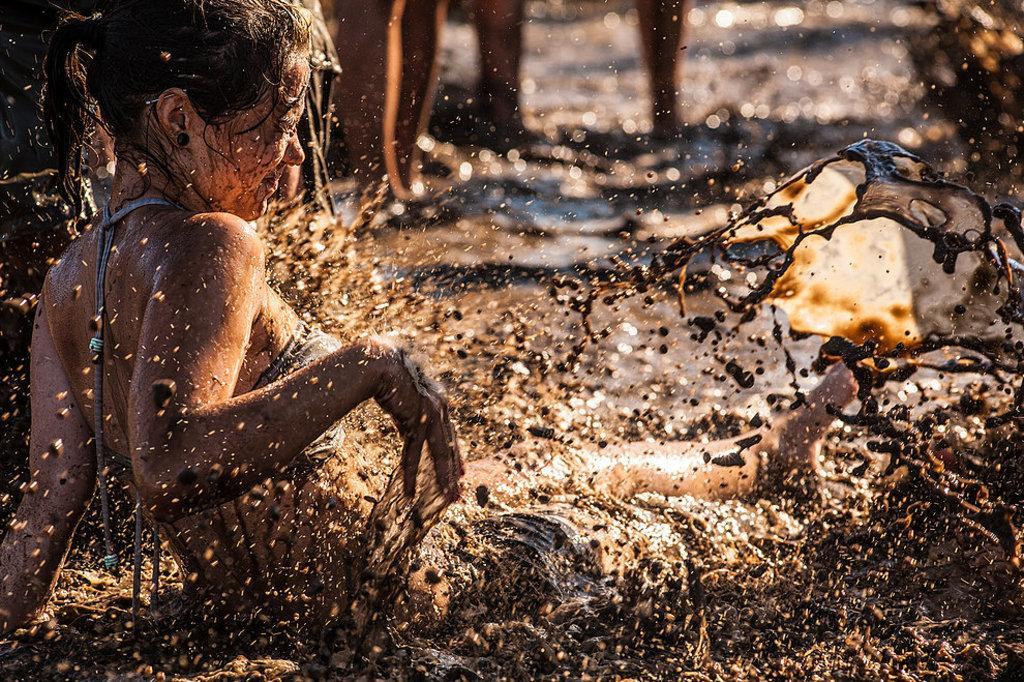Can you describe this image briefly? In this image in the center there is a woman playing in the muddy water. In the background there are persons standing. 